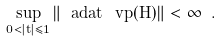<formula> <loc_0><loc_0><loc_500><loc_500>\sup _ { 0 < | t | \leq 1 } \| \ a d a t \, \ v p ( H ) \| < \infty \ .</formula> 